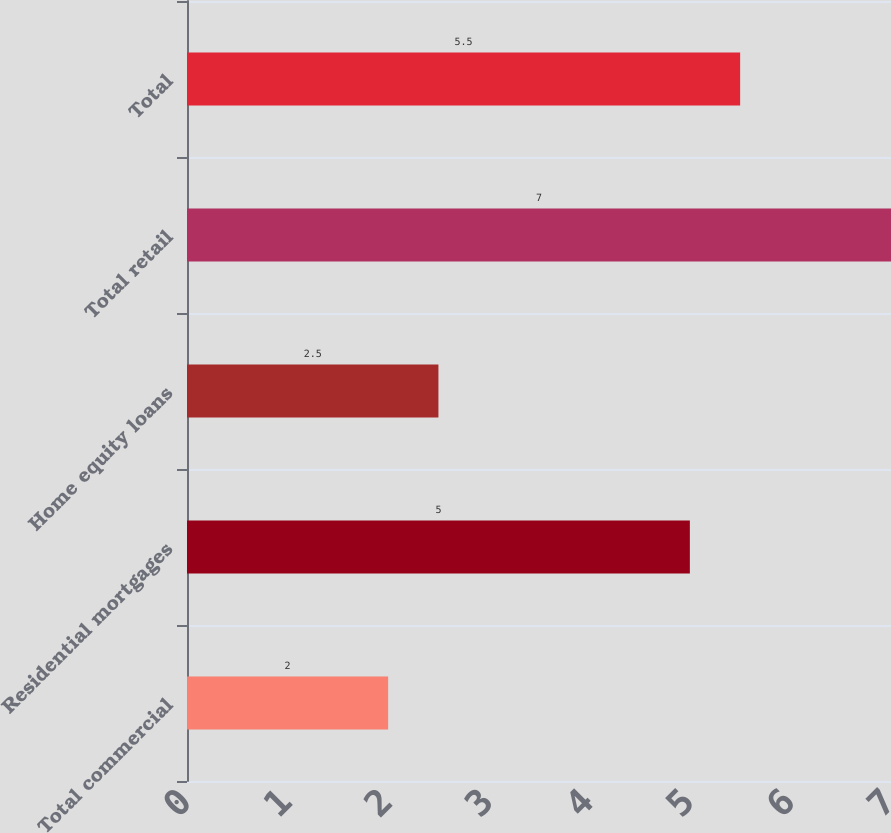Convert chart. <chart><loc_0><loc_0><loc_500><loc_500><bar_chart><fcel>Total commercial<fcel>Residential mortgages<fcel>Home equity loans<fcel>Total retail<fcel>Total<nl><fcel>2<fcel>5<fcel>2.5<fcel>7<fcel>5.5<nl></chart> 